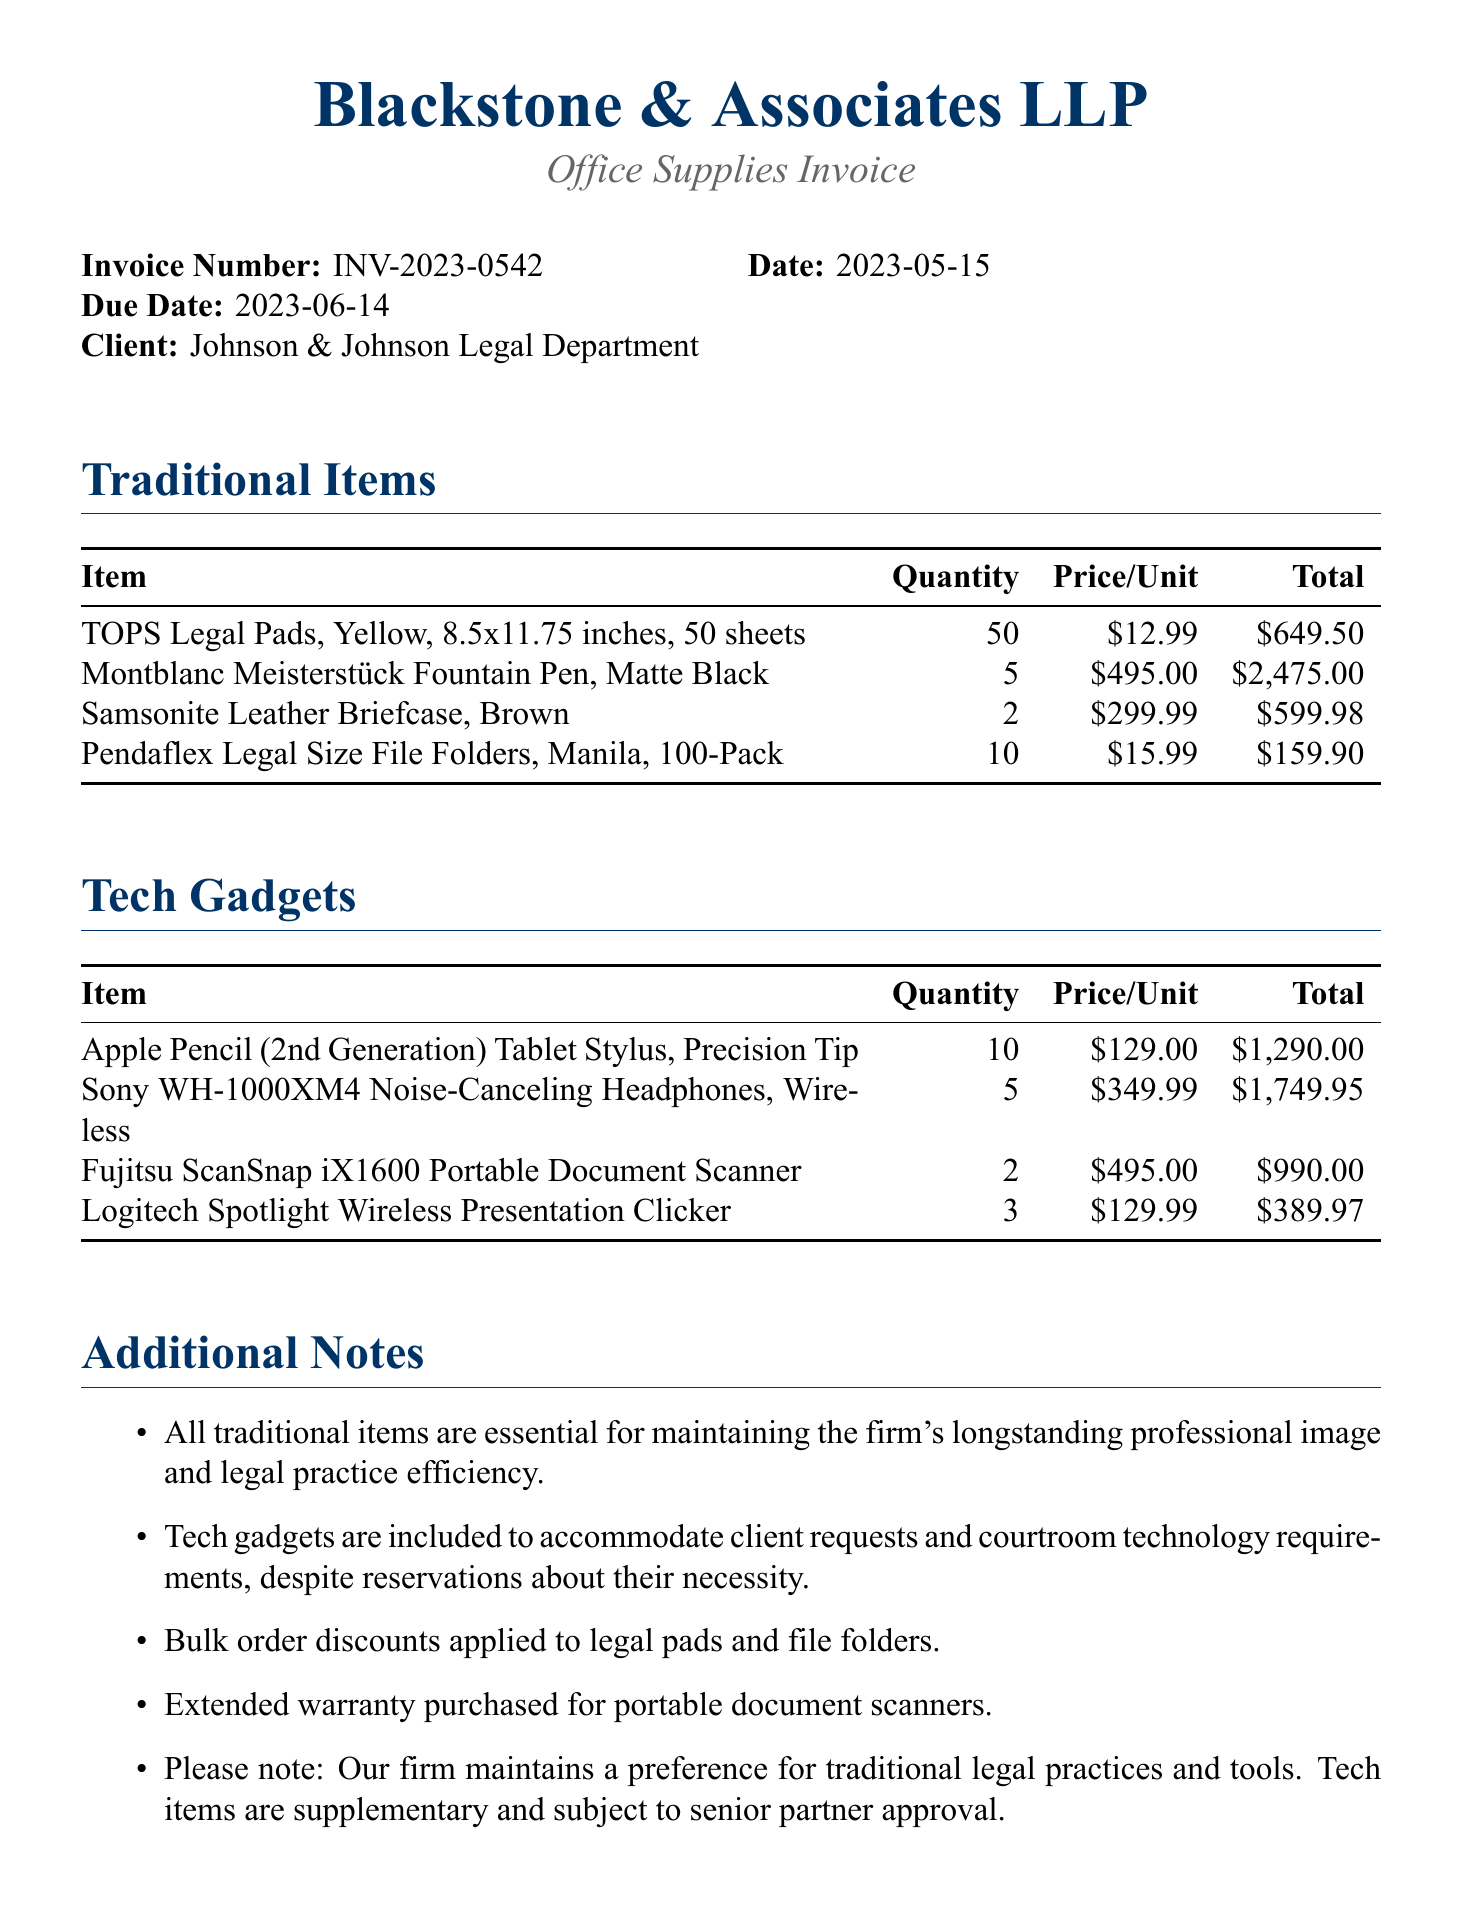What is the invoice number? The invoice number is clearly stated in the document under invoice details.
Answer: INV-2023-0542 What is the due date of the invoice? The due date is provided in the invoice details section.
Answer: 2023-06-14 How many legal pads were purchased? The quantity of legal pads is indicated in the traditional items section of the document.
Answer: 50 What is the total price for the noise-canceling headphones? The total for the noise-canceling headphones can be found in the tech gadgets section.
Answer: 1749.95 What percentage is applied as a late fee? The late fee percentage is mentioned under payment terms in the document.
Answer: 1.5% Which tech gadget requires an extended warranty? The document specifies that an extended warranty was purchased for a specific item in the additional notes.
Answer: Portable document scanners How much is the early payment discount? The early payment discount is outlined in the payment terms section of the invoice.
Answer: 2% What is the subtotal amount before tax? The subtotal can be found in the total amount section of the invoice.
Answer: 8304.30 What is the total amount including tax? The grand total is presented at the end of the total amount section.
Answer: 8968.64 